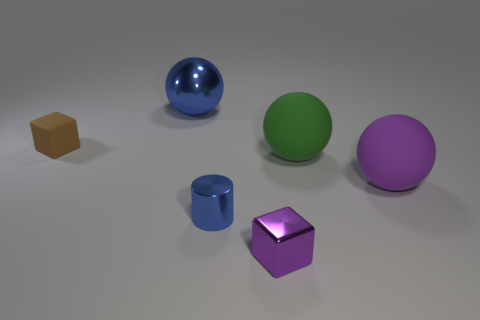Subtract all yellow cubes. Subtract all brown spheres. How many cubes are left? 2 Add 3 blue metal cylinders. How many objects exist? 9 Subtract all cylinders. How many objects are left? 5 Subtract all large red cylinders. Subtract all small blue metallic cylinders. How many objects are left? 5 Add 6 green matte balls. How many green matte balls are left? 7 Add 2 large balls. How many large balls exist? 5 Subtract 0 cyan blocks. How many objects are left? 6 